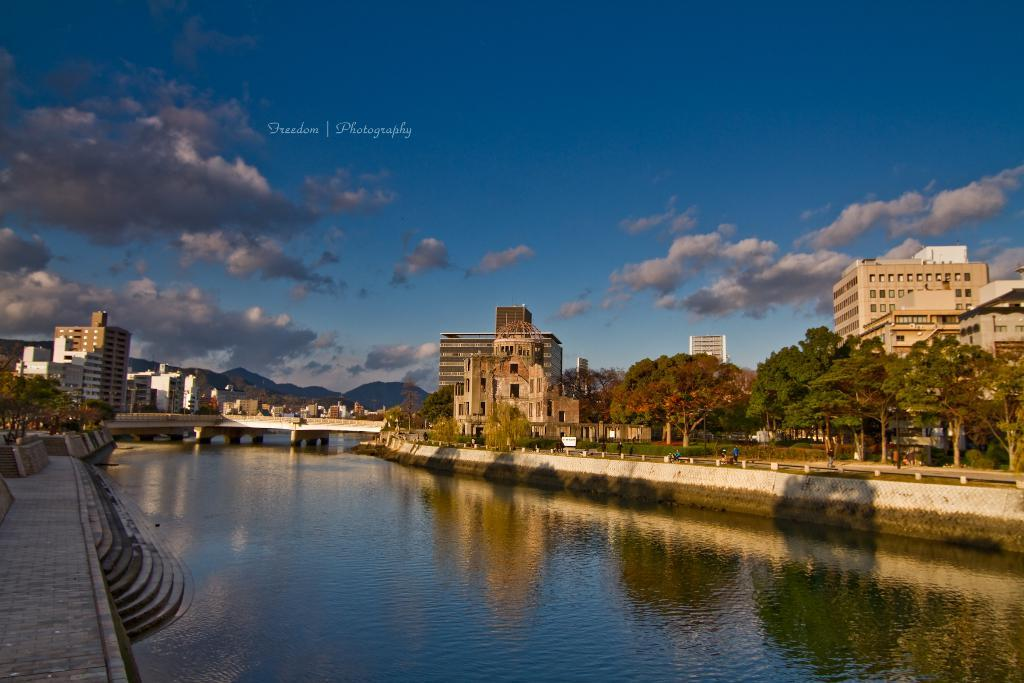What is the primary element present in the image? There is water in the image. What structure can be seen crossing over the water? There is a bridge in the image. What architectural features are present near the water? There are walls and steps in the image. What type of vegetation is visible in the image? There are trees in the image. What type of man-made structures can be seen in the image? There are buildings in the image. What natural landforms are present in the image? There are mountains in the image. What else can be seen in the image besides the water and structures? There are objects and people in the image. What is visible in the background of the image? The sky is visible in the background of the image, with clouds present. Where is the nest located in the image? There is no nest present in the image. What type of park can be seen in the background of the image? There is no park present in the image. 